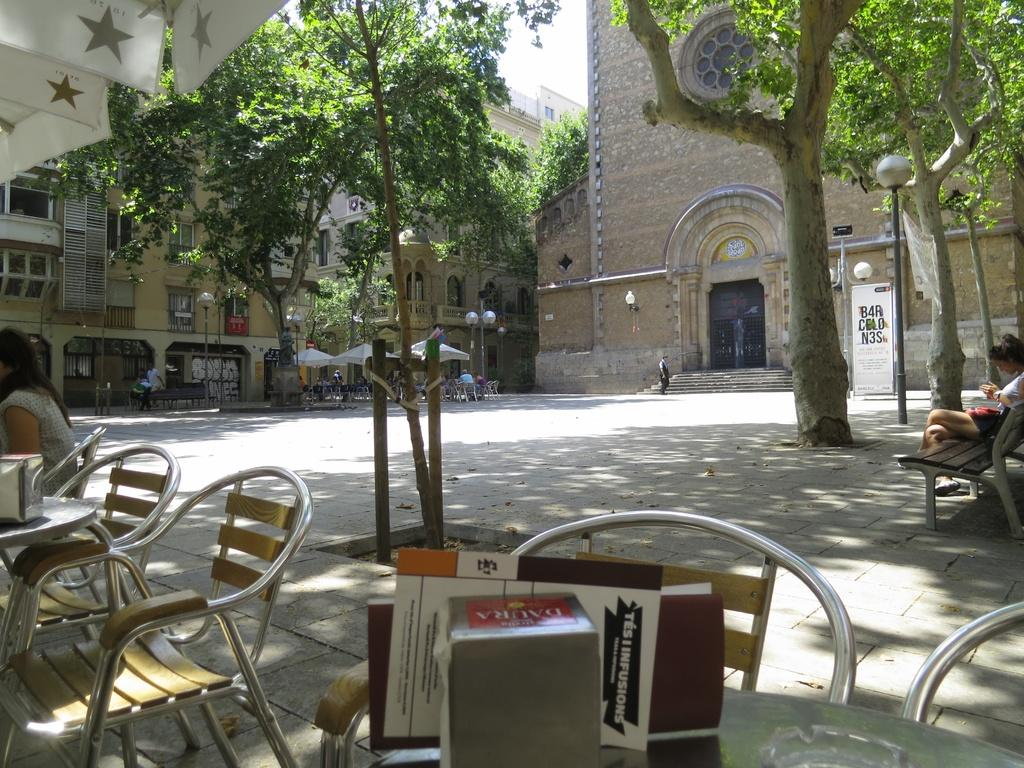What type of structures can be seen in the image? There are buildings in the image. What are the poles with lamps used for in the image? The poles with lamps provide lighting in the image. What type of furniture is present in the image? There are chairs in the image. Who or what is present in the image besides the buildings and furniture? There are people and trees in the image. What type of band is playing in the background of the image? There is no band present in the image. What direction are the people facing in the image? The provided facts do not specify the direction the people are facing, so we cannot answer this question definitively. 